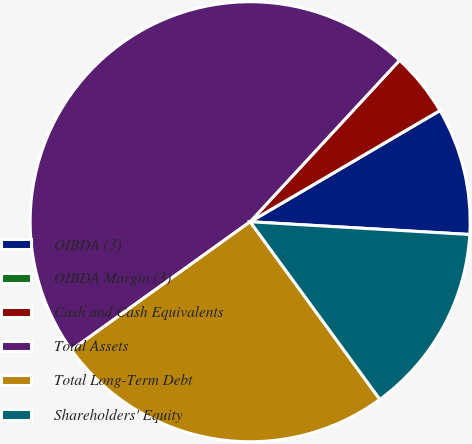Convert chart to OTSL. <chart><loc_0><loc_0><loc_500><loc_500><pie_chart><fcel>OIBDA (3)<fcel>OIBDA Margin (3)<fcel>Cash and Cash Equivalents<fcel>Total Assets<fcel>Total Long-Term Debt<fcel>Shareholders' Equity<nl><fcel>9.36%<fcel>0.0%<fcel>4.68%<fcel>46.79%<fcel>25.13%<fcel>14.04%<nl></chart> 